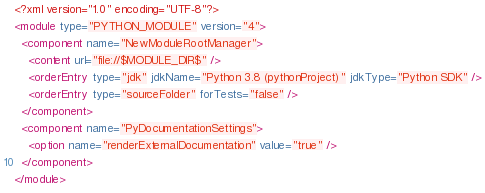Convert code to text. <code><loc_0><loc_0><loc_500><loc_500><_XML_><?xml version="1.0" encoding="UTF-8"?>
<module type="PYTHON_MODULE" version="4">
  <component name="NewModuleRootManager">
    <content url="file://$MODULE_DIR$" />
    <orderEntry type="jdk" jdkName="Python 3.8 (pythonProject)" jdkType="Python SDK" />
    <orderEntry type="sourceFolder" forTests="false" />
  </component>
  <component name="PyDocumentationSettings">
    <option name="renderExternalDocumentation" value="true" />
  </component>
</module></code> 